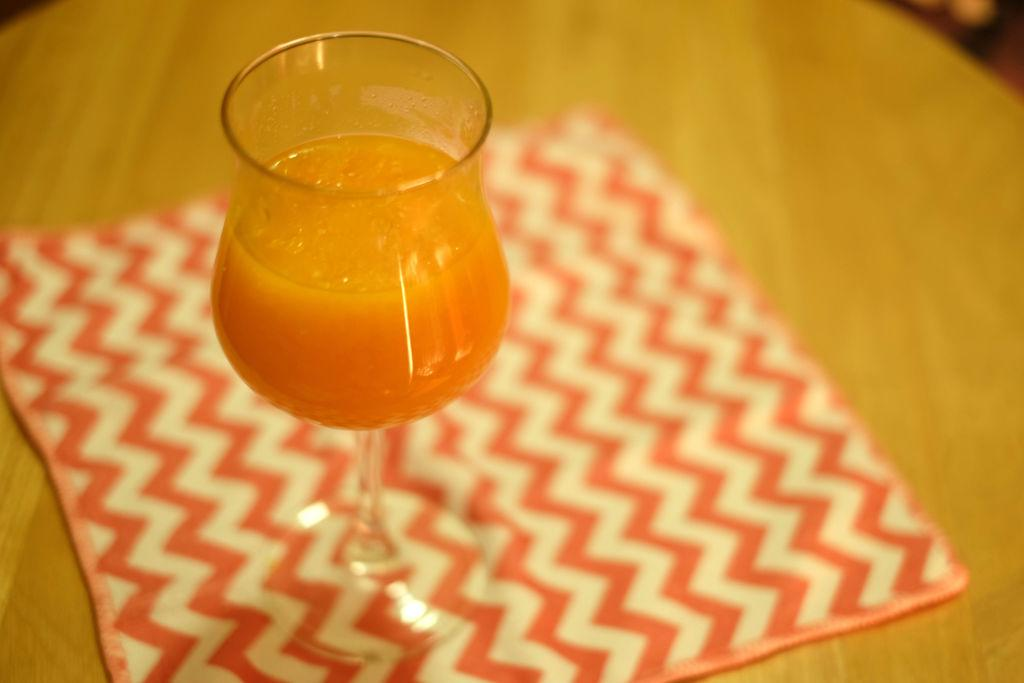What piece of furniture is present in the image? There is a table in the image. What is covering the table? There is a cloth on the table. What is placed on top of the cloth? There is a glass on the table. What is inside the glass? There is a drink in the glass. How many stars can be seen on the tablecloth in the image? There are no stars visible on the tablecloth in the image. Are there any cats present on the table in the image? There are no cats present on the table in the image. 